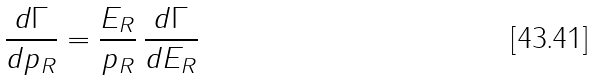<formula> <loc_0><loc_0><loc_500><loc_500>\frac { d \Gamma } { d p _ { R } } = \frac { E _ { R } } { p _ { R } } \, \frac { d \Gamma } { d E _ { R } }</formula> 